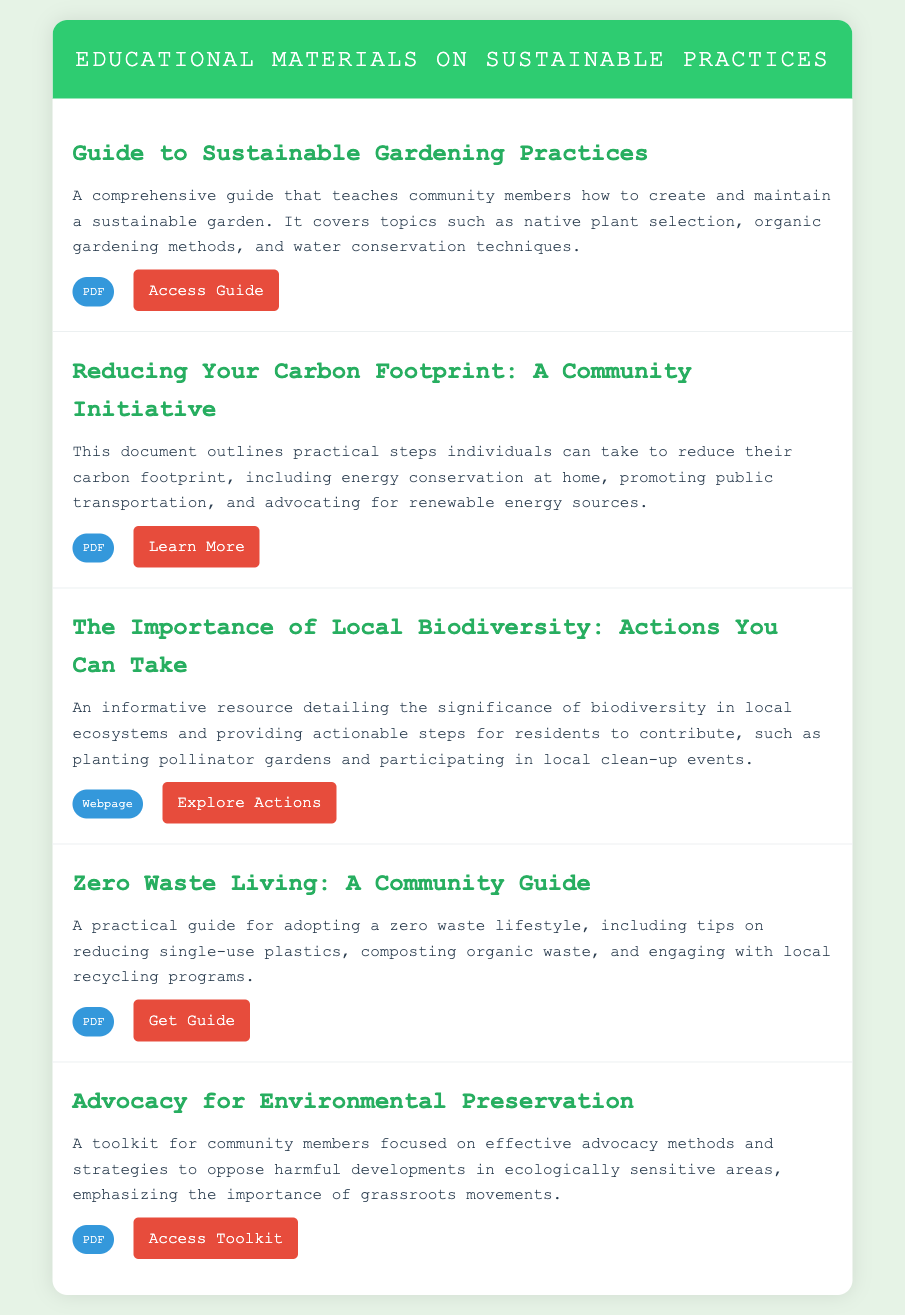what is the title of the first item? The title of the first item in the document is listed at the top of the first menu item.
Answer: Guide to Sustainable Gardening Practices how many PDF resources are listed? The document states that there are five items, and four of them are labeled as PDF resources.
Answer: 4 what is the main focus of the second item? The main focus of the second item is described in the summary of the document, which outlines practical steps for reducing carbon footprints.
Answer: Reducing carbon footprint what is the type of the third resource? The type of the third resource can be found in the resource type label next to its title within the menu structure.
Answer: Webpage which item provides a toolkit for advocacy? The document clearly lists advocacy resources under a specific title that mentions toolkit and advocacy methods.
Answer: Advocacy for Environmental Preservation what action is suggested in the fourth item? The fourth item outlines specific actions related to a lifestyle change and mentions reducing single-use plastics as a key point.
Answer: Reducing single-use plastics what is the emphasis of the last resource? The emphasis of the last resource relates to the strategies to oppose harmful developments in ecologically sensitive areas, as detailed in the summary.
Answer: Grassroots movements 